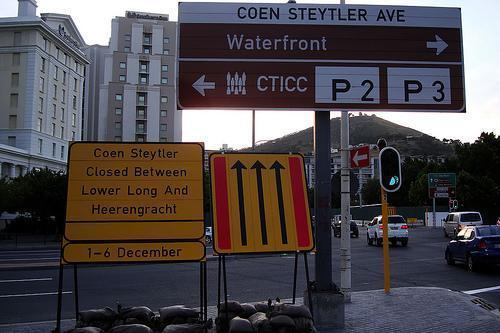How many signs are yellow?
Give a very brief answer. 2. How many arrows are on the sign?
Give a very brief answer. 3. How many arrows are pointing up?
Give a very brief answer. 3. 